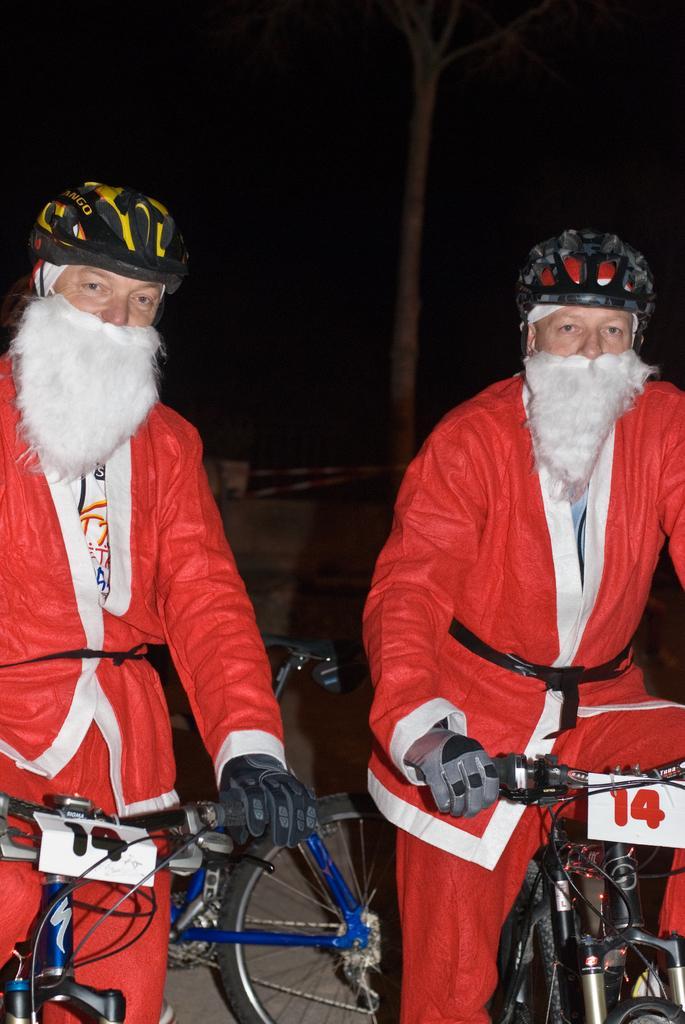How would you summarize this image in a sentence or two? In this image we can see two persons wearing Santa Claus dress is sitting on the bicycle. They are also wearing helmets on their head. We can see one more bicycle in the background. 